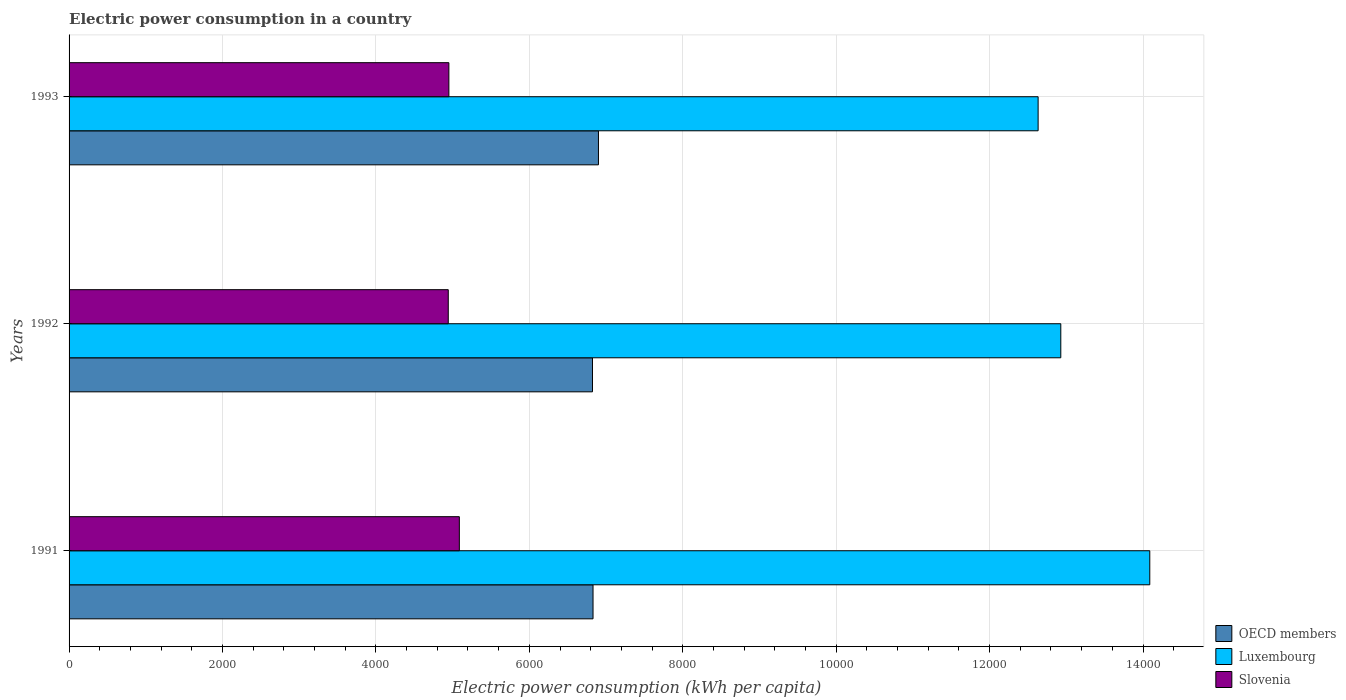How many different coloured bars are there?
Your response must be concise. 3. How many groups of bars are there?
Your answer should be very brief. 3. Are the number of bars on each tick of the Y-axis equal?
Your answer should be very brief. Yes. How many bars are there on the 2nd tick from the bottom?
Keep it short and to the point. 3. What is the label of the 3rd group of bars from the top?
Provide a short and direct response. 1991. What is the electric power consumption in in Luxembourg in 1991?
Offer a terse response. 1.41e+04. Across all years, what is the maximum electric power consumption in in Luxembourg?
Make the answer very short. 1.41e+04. Across all years, what is the minimum electric power consumption in in OECD members?
Give a very brief answer. 6823.05. What is the total electric power consumption in in Luxembourg in the graph?
Keep it short and to the point. 3.96e+04. What is the difference between the electric power consumption in in Slovenia in 1991 and that in 1993?
Your answer should be compact. 136.52. What is the difference between the electric power consumption in in OECD members in 1992 and the electric power consumption in in Slovenia in 1991?
Your answer should be very brief. 1735.6. What is the average electric power consumption in in OECD members per year?
Provide a short and direct response. 6851.37. In the year 1991, what is the difference between the electric power consumption in in OECD members and electric power consumption in in Luxembourg?
Give a very brief answer. -7257.75. What is the ratio of the electric power consumption in in Luxembourg in 1991 to that in 1992?
Offer a terse response. 1.09. What is the difference between the highest and the second highest electric power consumption in in OECD members?
Your response must be concise. 70.85. What is the difference between the highest and the lowest electric power consumption in in Luxembourg?
Your response must be concise. 1455.61. In how many years, is the electric power consumption in in OECD members greater than the average electric power consumption in in OECD members taken over all years?
Your response must be concise. 1. Is the sum of the electric power consumption in in OECD members in 1991 and 1992 greater than the maximum electric power consumption in in Slovenia across all years?
Provide a succinct answer. Yes. What does the 2nd bar from the top in 1991 represents?
Your answer should be compact. Luxembourg. What does the 1st bar from the bottom in 1991 represents?
Ensure brevity in your answer.  OECD members. Are all the bars in the graph horizontal?
Give a very brief answer. Yes. Are the values on the major ticks of X-axis written in scientific E-notation?
Offer a very short reply. No. Does the graph contain any zero values?
Make the answer very short. No. Does the graph contain grids?
Ensure brevity in your answer.  Yes. Where does the legend appear in the graph?
Provide a short and direct response. Bottom right. How many legend labels are there?
Your answer should be compact. 3. What is the title of the graph?
Provide a succinct answer. Electric power consumption in a country. Does "Zambia" appear as one of the legend labels in the graph?
Give a very brief answer. No. What is the label or title of the X-axis?
Keep it short and to the point. Electric power consumption (kWh per capita). What is the label or title of the Y-axis?
Make the answer very short. Years. What is the Electric power consumption (kWh per capita) in OECD members in 1991?
Keep it short and to the point. 6830.11. What is the Electric power consumption (kWh per capita) of Luxembourg in 1991?
Offer a very short reply. 1.41e+04. What is the Electric power consumption (kWh per capita) of Slovenia in 1991?
Offer a terse response. 5087.45. What is the Electric power consumption (kWh per capita) in OECD members in 1992?
Your response must be concise. 6823.05. What is the Electric power consumption (kWh per capita) of Luxembourg in 1992?
Your answer should be very brief. 1.29e+04. What is the Electric power consumption (kWh per capita) of Slovenia in 1992?
Ensure brevity in your answer.  4943.16. What is the Electric power consumption (kWh per capita) in OECD members in 1993?
Offer a terse response. 6900.96. What is the Electric power consumption (kWh per capita) of Luxembourg in 1993?
Your answer should be very brief. 1.26e+04. What is the Electric power consumption (kWh per capita) of Slovenia in 1993?
Offer a terse response. 4950.93. Across all years, what is the maximum Electric power consumption (kWh per capita) of OECD members?
Your response must be concise. 6900.96. Across all years, what is the maximum Electric power consumption (kWh per capita) in Luxembourg?
Give a very brief answer. 1.41e+04. Across all years, what is the maximum Electric power consumption (kWh per capita) in Slovenia?
Make the answer very short. 5087.45. Across all years, what is the minimum Electric power consumption (kWh per capita) of OECD members?
Offer a very short reply. 6823.05. Across all years, what is the minimum Electric power consumption (kWh per capita) in Luxembourg?
Ensure brevity in your answer.  1.26e+04. Across all years, what is the minimum Electric power consumption (kWh per capita) of Slovenia?
Your answer should be very brief. 4943.16. What is the total Electric power consumption (kWh per capita) in OECD members in the graph?
Provide a short and direct response. 2.06e+04. What is the total Electric power consumption (kWh per capita) of Luxembourg in the graph?
Your answer should be compact. 3.96e+04. What is the total Electric power consumption (kWh per capita) in Slovenia in the graph?
Offer a very short reply. 1.50e+04. What is the difference between the Electric power consumption (kWh per capita) of OECD members in 1991 and that in 1992?
Offer a terse response. 7.06. What is the difference between the Electric power consumption (kWh per capita) in Luxembourg in 1991 and that in 1992?
Keep it short and to the point. 1159.95. What is the difference between the Electric power consumption (kWh per capita) of Slovenia in 1991 and that in 1992?
Make the answer very short. 144.3. What is the difference between the Electric power consumption (kWh per capita) of OECD members in 1991 and that in 1993?
Provide a succinct answer. -70.85. What is the difference between the Electric power consumption (kWh per capita) of Luxembourg in 1991 and that in 1993?
Your answer should be very brief. 1455.61. What is the difference between the Electric power consumption (kWh per capita) in Slovenia in 1991 and that in 1993?
Offer a terse response. 136.52. What is the difference between the Electric power consumption (kWh per capita) in OECD members in 1992 and that in 1993?
Provide a succinct answer. -77.91. What is the difference between the Electric power consumption (kWh per capita) in Luxembourg in 1992 and that in 1993?
Provide a short and direct response. 295.66. What is the difference between the Electric power consumption (kWh per capita) in Slovenia in 1992 and that in 1993?
Provide a succinct answer. -7.78. What is the difference between the Electric power consumption (kWh per capita) of OECD members in 1991 and the Electric power consumption (kWh per capita) of Luxembourg in 1992?
Give a very brief answer. -6097.8. What is the difference between the Electric power consumption (kWh per capita) of OECD members in 1991 and the Electric power consumption (kWh per capita) of Slovenia in 1992?
Offer a very short reply. 1886.95. What is the difference between the Electric power consumption (kWh per capita) in Luxembourg in 1991 and the Electric power consumption (kWh per capita) in Slovenia in 1992?
Make the answer very short. 9144.7. What is the difference between the Electric power consumption (kWh per capita) in OECD members in 1991 and the Electric power consumption (kWh per capita) in Luxembourg in 1993?
Offer a terse response. -5802.13. What is the difference between the Electric power consumption (kWh per capita) of OECD members in 1991 and the Electric power consumption (kWh per capita) of Slovenia in 1993?
Provide a succinct answer. 1879.17. What is the difference between the Electric power consumption (kWh per capita) in Luxembourg in 1991 and the Electric power consumption (kWh per capita) in Slovenia in 1993?
Give a very brief answer. 9136.92. What is the difference between the Electric power consumption (kWh per capita) of OECD members in 1992 and the Electric power consumption (kWh per capita) of Luxembourg in 1993?
Provide a succinct answer. -5809.19. What is the difference between the Electric power consumption (kWh per capita) in OECD members in 1992 and the Electric power consumption (kWh per capita) in Slovenia in 1993?
Provide a succinct answer. 1872.12. What is the difference between the Electric power consumption (kWh per capita) in Luxembourg in 1992 and the Electric power consumption (kWh per capita) in Slovenia in 1993?
Give a very brief answer. 7976.97. What is the average Electric power consumption (kWh per capita) in OECD members per year?
Your response must be concise. 6851.37. What is the average Electric power consumption (kWh per capita) in Luxembourg per year?
Ensure brevity in your answer.  1.32e+04. What is the average Electric power consumption (kWh per capita) of Slovenia per year?
Provide a succinct answer. 4993.85. In the year 1991, what is the difference between the Electric power consumption (kWh per capita) of OECD members and Electric power consumption (kWh per capita) of Luxembourg?
Make the answer very short. -7257.75. In the year 1991, what is the difference between the Electric power consumption (kWh per capita) of OECD members and Electric power consumption (kWh per capita) of Slovenia?
Give a very brief answer. 1742.65. In the year 1991, what is the difference between the Electric power consumption (kWh per capita) in Luxembourg and Electric power consumption (kWh per capita) in Slovenia?
Keep it short and to the point. 9000.4. In the year 1992, what is the difference between the Electric power consumption (kWh per capita) of OECD members and Electric power consumption (kWh per capita) of Luxembourg?
Make the answer very short. -6104.85. In the year 1992, what is the difference between the Electric power consumption (kWh per capita) in OECD members and Electric power consumption (kWh per capita) in Slovenia?
Give a very brief answer. 1879.9. In the year 1992, what is the difference between the Electric power consumption (kWh per capita) of Luxembourg and Electric power consumption (kWh per capita) of Slovenia?
Provide a succinct answer. 7984.75. In the year 1993, what is the difference between the Electric power consumption (kWh per capita) of OECD members and Electric power consumption (kWh per capita) of Luxembourg?
Provide a short and direct response. -5731.28. In the year 1993, what is the difference between the Electric power consumption (kWh per capita) of OECD members and Electric power consumption (kWh per capita) of Slovenia?
Your response must be concise. 1950.03. In the year 1993, what is the difference between the Electric power consumption (kWh per capita) of Luxembourg and Electric power consumption (kWh per capita) of Slovenia?
Give a very brief answer. 7681.31. What is the ratio of the Electric power consumption (kWh per capita) of OECD members in 1991 to that in 1992?
Offer a very short reply. 1. What is the ratio of the Electric power consumption (kWh per capita) of Luxembourg in 1991 to that in 1992?
Provide a succinct answer. 1.09. What is the ratio of the Electric power consumption (kWh per capita) in Slovenia in 1991 to that in 1992?
Your answer should be very brief. 1.03. What is the ratio of the Electric power consumption (kWh per capita) of Luxembourg in 1991 to that in 1993?
Your answer should be compact. 1.12. What is the ratio of the Electric power consumption (kWh per capita) of Slovenia in 1991 to that in 1993?
Your response must be concise. 1.03. What is the ratio of the Electric power consumption (kWh per capita) in OECD members in 1992 to that in 1993?
Make the answer very short. 0.99. What is the ratio of the Electric power consumption (kWh per capita) in Luxembourg in 1992 to that in 1993?
Offer a very short reply. 1.02. What is the difference between the highest and the second highest Electric power consumption (kWh per capita) of OECD members?
Keep it short and to the point. 70.85. What is the difference between the highest and the second highest Electric power consumption (kWh per capita) of Luxembourg?
Make the answer very short. 1159.95. What is the difference between the highest and the second highest Electric power consumption (kWh per capita) in Slovenia?
Keep it short and to the point. 136.52. What is the difference between the highest and the lowest Electric power consumption (kWh per capita) in OECD members?
Your response must be concise. 77.91. What is the difference between the highest and the lowest Electric power consumption (kWh per capita) of Luxembourg?
Give a very brief answer. 1455.61. What is the difference between the highest and the lowest Electric power consumption (kWh per capita) of Slovenia?
Provide a short and direct response. 144.3. 